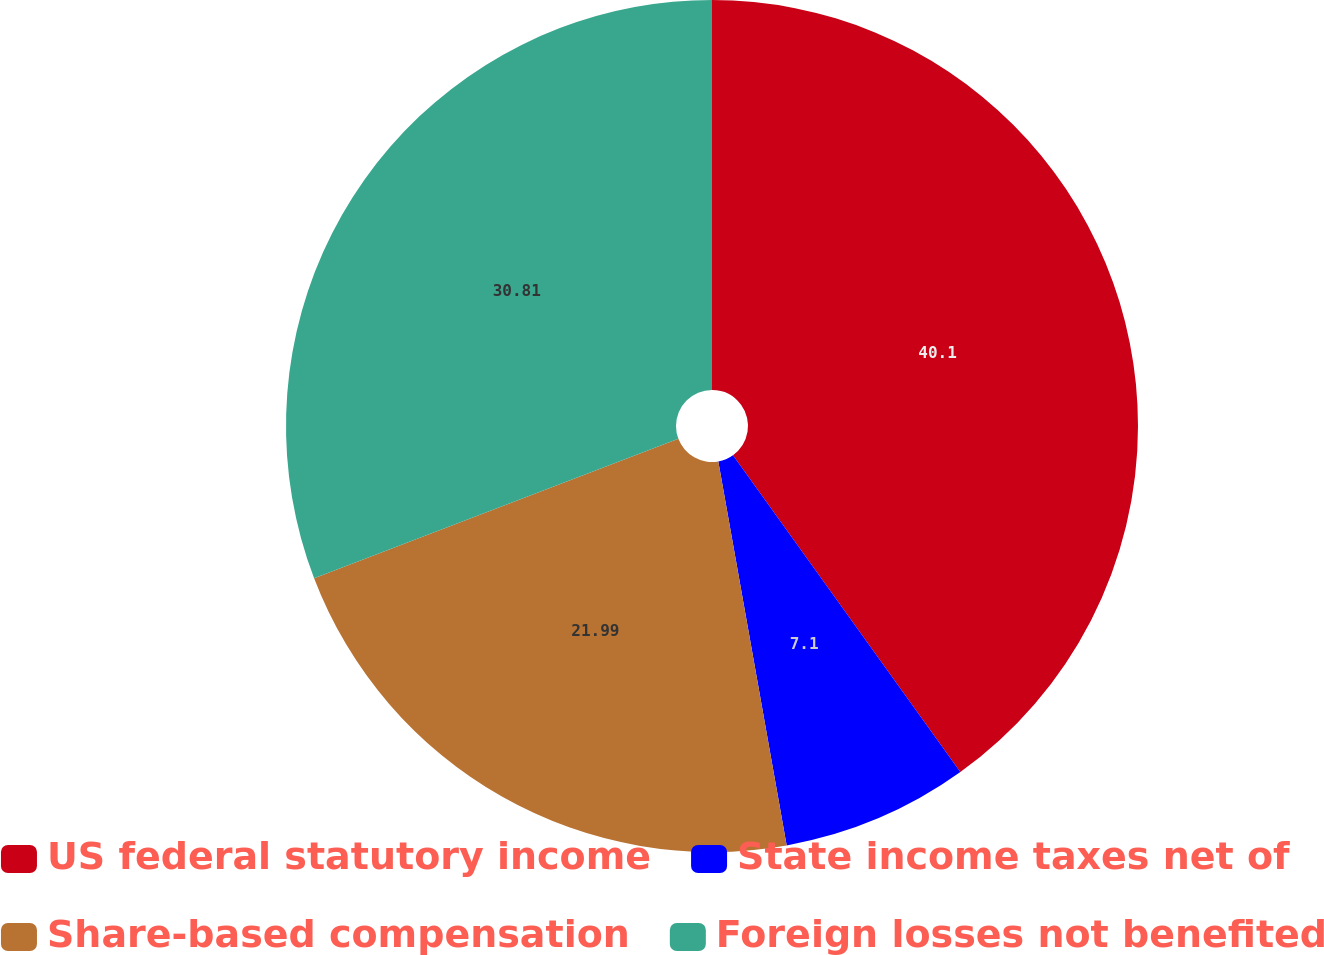<chart> <loc_0><loc_0><loc_500><loc_500><pie_chart><fcel>US federal statutory income<fcel>State income taxes net of<fcel>Share-based compensation<fcel>Foreign losses not benefited<nl><fcel>40.09%<fcel>7.1%<fcel>21.99%<fcel>30.81%<nl></chart> 